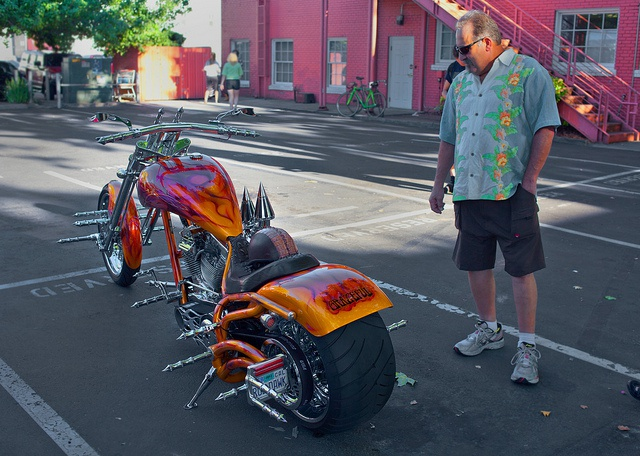Describe the objects in this image and their specific colors. I can see motorcycle in darkgreen, black, gray, navy, and maroon tones, people in darkgreen, black, and gray tones, bicycle in darkgreen, gray, teal, black, and purple tones, car in darkgreen, black, gray, and blue tones, and people in darkgreen, teal, gray, darkgray, and navy tones in this image. 